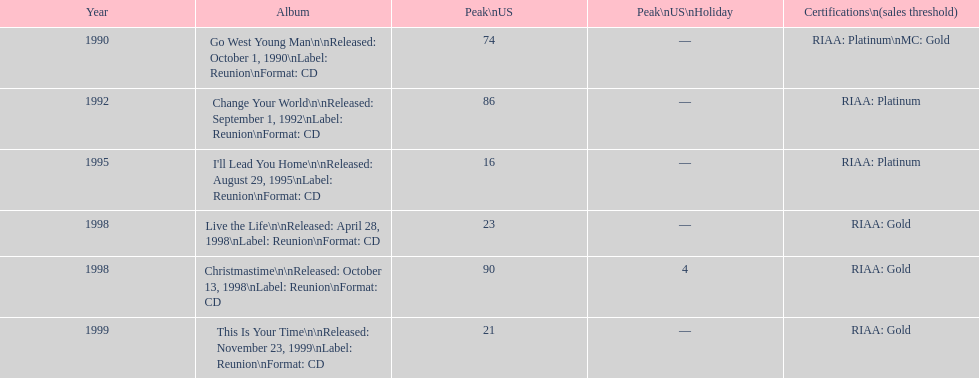Which album reached the minimum peak position in the us? I'll Lead You Home. 